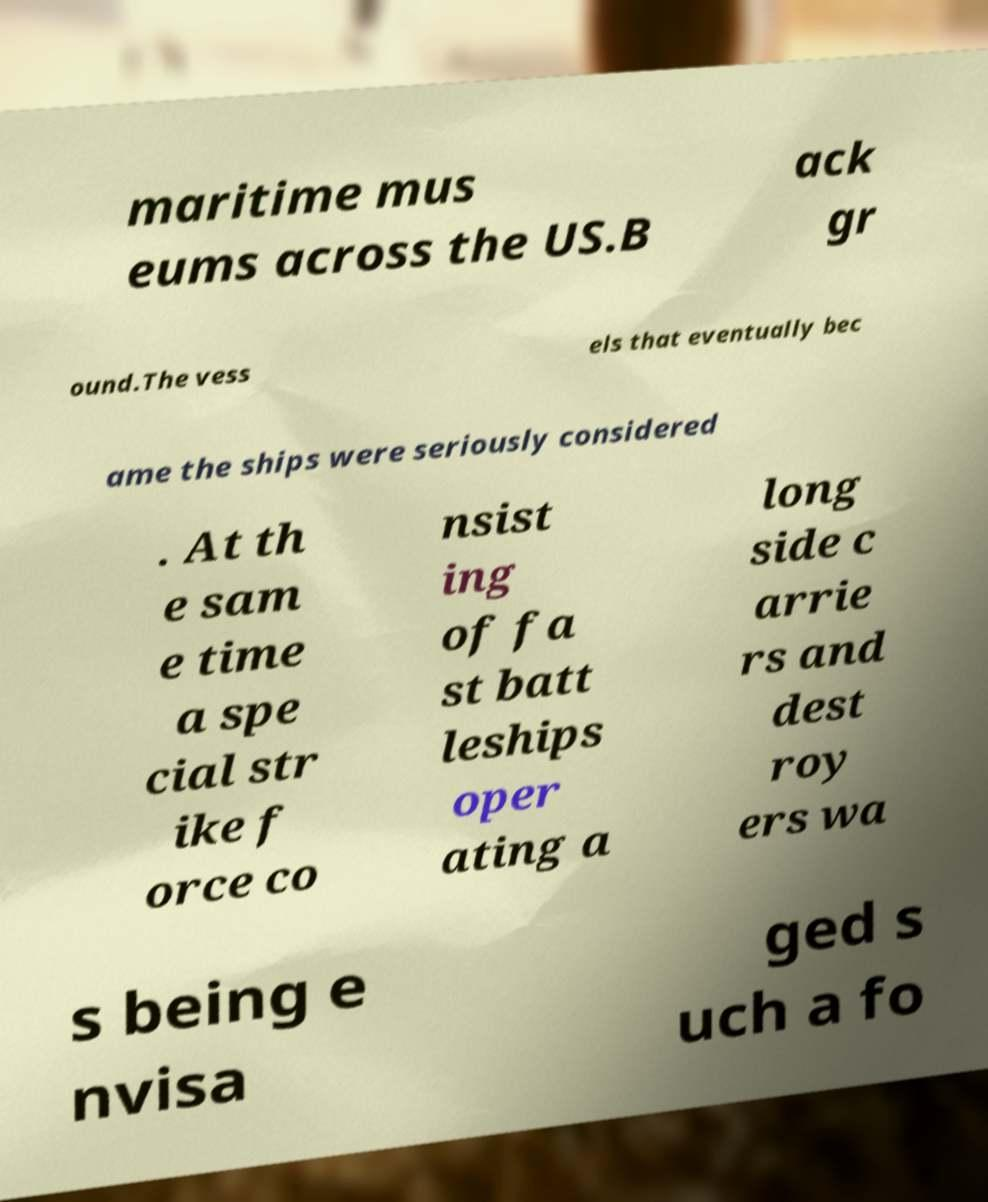Could you extract and type out the text from this image? maritime mus eums across the US.B ack gr ound.The vess els that eventually bec ame the ships were seriously considered . At th e sam e time a spe cial str ike f orce co nsist ing of fa st batt leships oper ating a long side c arrie rs and dest roy ers wa s being e nvisa ged s uch a fo 